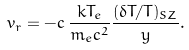<formula> <loc_0><loc_0><loc_500><loc_500>v _ { r } = - c \, \frac { k T _ { e } } { m _ { e } c ^ { 2 } } \frac { ( \delta T / T ) _ { S Z } } { y } .</formula> 